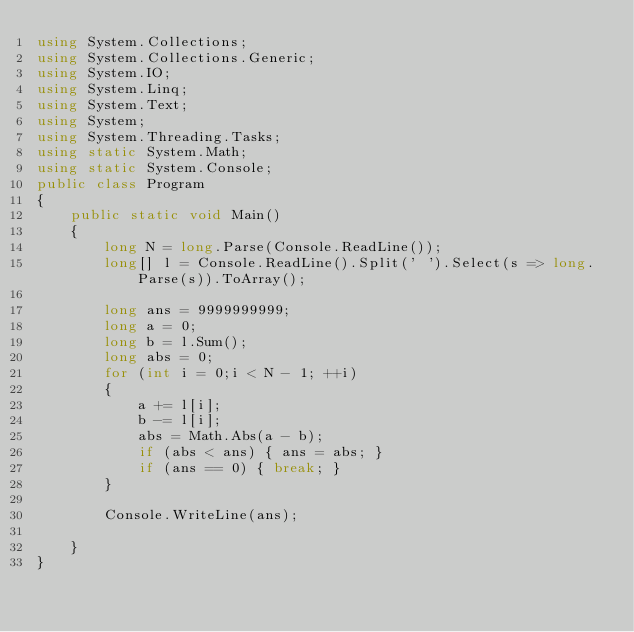<code> <loc_0><loc_0><loc_500><loc_500><_C#_>using System.Collections;
using System.Collections.Generic;
using System.IO;
using System.Linq;
using System.Text;
using System;
using System.Threading.Tasks;
using static System.Math;
using static System.Console;
public class Program
{
    public static void Main()
    {
        long N = long.Parse(Console.ReadLine());
        long[] l = Console.ReadLine().Split(' ').Select(s => long.Parse(s)).ToArray();

        long ans = 9999999999;
        long a = 0;
        long b = l.Sum();
        long abs = 0;
        for (int i = 0;i < N - 1; ++i)
        {
            a += l[i];
            b -= l[i];
            abs = Math.Abs(a - b);
            if (abs < ans) { ans = abs; }
            if (ans == 0) { break; }
        }

        Console.WriteLine(ans);
        
    }
}</code> 